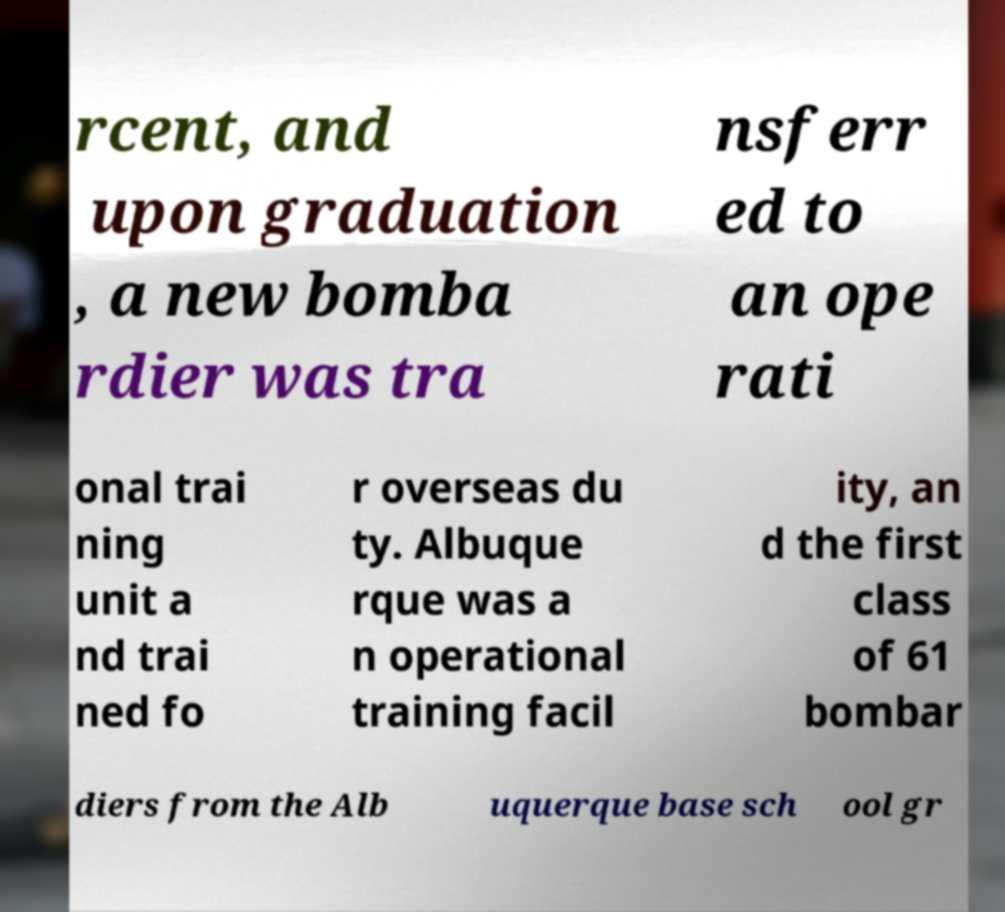Can you read and provide the text displayed in the image?This photo seems to have some interesting text. Can you extract and type it out for me? rcent, and upon graduation , a new bomba rdier was tra nsferr ed to an ope rati onal trai ning unit a nd trai ned fo r overseas du ty. Albuque rque was a n operational training facil ity, an d the first class of 61 bombar diers from the Alb uquerque base sch ool gr 